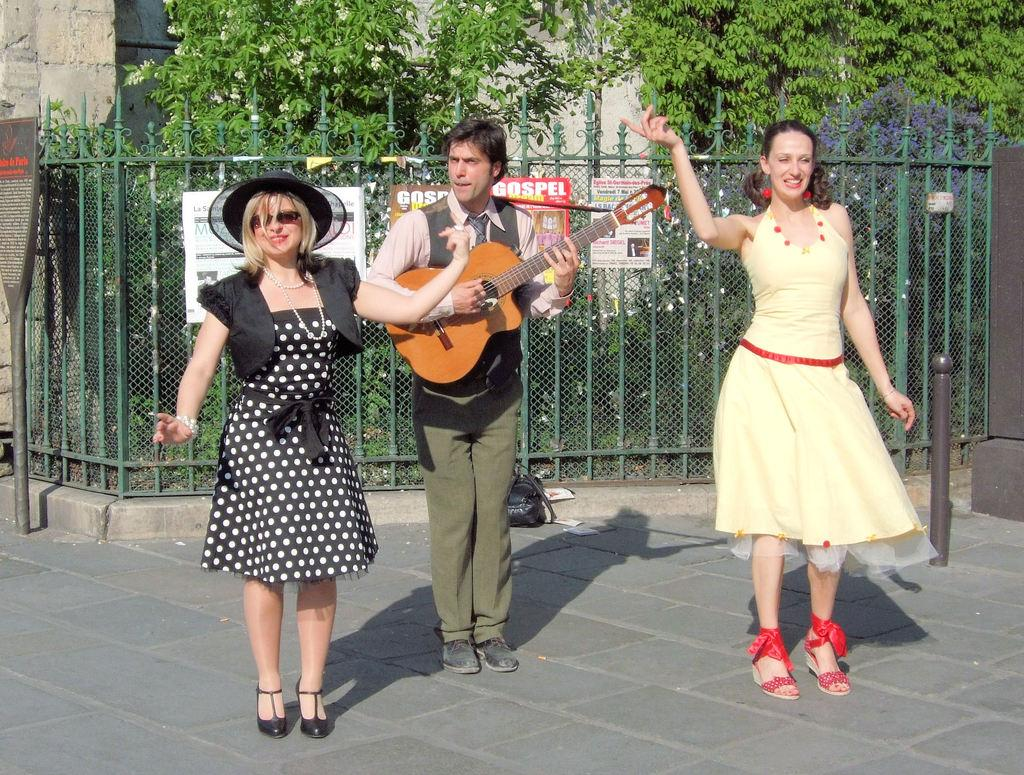How many people are standing on the road in the image? There are three persons standing on the road in the image. What is one of the persons holding? One of the persons is holding a guitar. What can be seen in the background of the image? There are trees visible at the back side of the image. What type of hand can be seen holding a print in the image? There is no hand or print present in the image. 